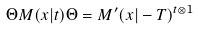<formula> <loc_0><loc_0><loc_500><loc_500>\Theta M ( x | t ) \Theta = M ^ { \prime } ( x | - T ) ^ { t \otimes 1 }</formula> 